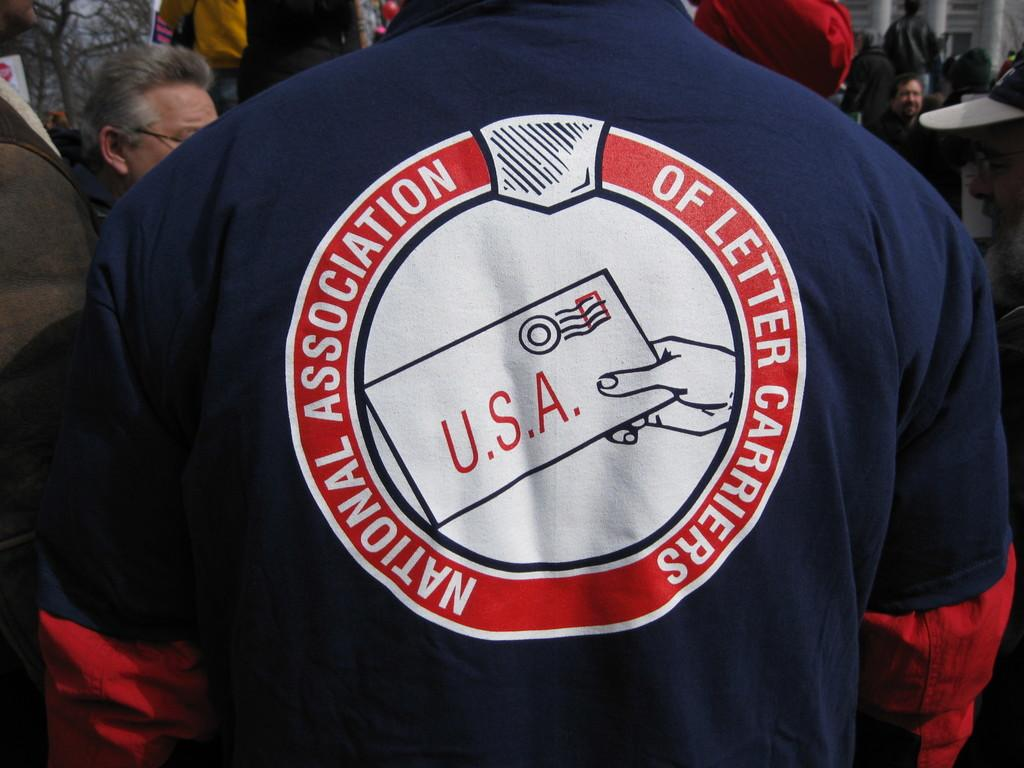<image>
Write a terse but informative summary of the picture. The person in the image works for The National Association of Letter Carriers 